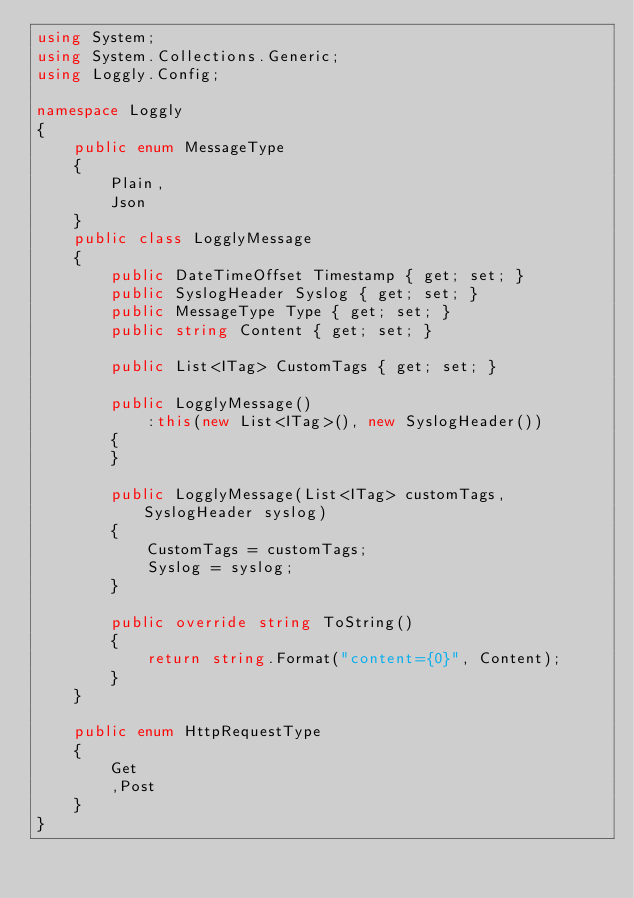Convert code to text. <code><loc_0><loc_0><loc_500><loc_500><_C#_>using System;
using System.Collections.Generic;
using Loggly.Config;

namespace Loggly
{
    public enum MessageType
    {
        Plain,
        Json
    }
    public class LogglyMessage
    {
        public DateTimeOffset Timestamp { get; set; }
        public SyslogHeader Syslog { get; set; }
        public MessageType Type { get; set; }
        public string Content { get; set; }

        public List<ITag> CustomTags { get; set; }

        public LogglyMessage()
            :this(new List<ITag>(), new SyslogHeader())
        {
        }

        public LogglyMessage(List<ITag> customTags, SyslogHeader syslog)
        {
            CustomTags = customTags;
            Syslog = syslog;
        }

        public override string ToString()
        {
            return string.Format("content={0}", Content);
        }
    }

    public enum HttpRequestType
    {
        Get
        ,Post
    }
}</code> 